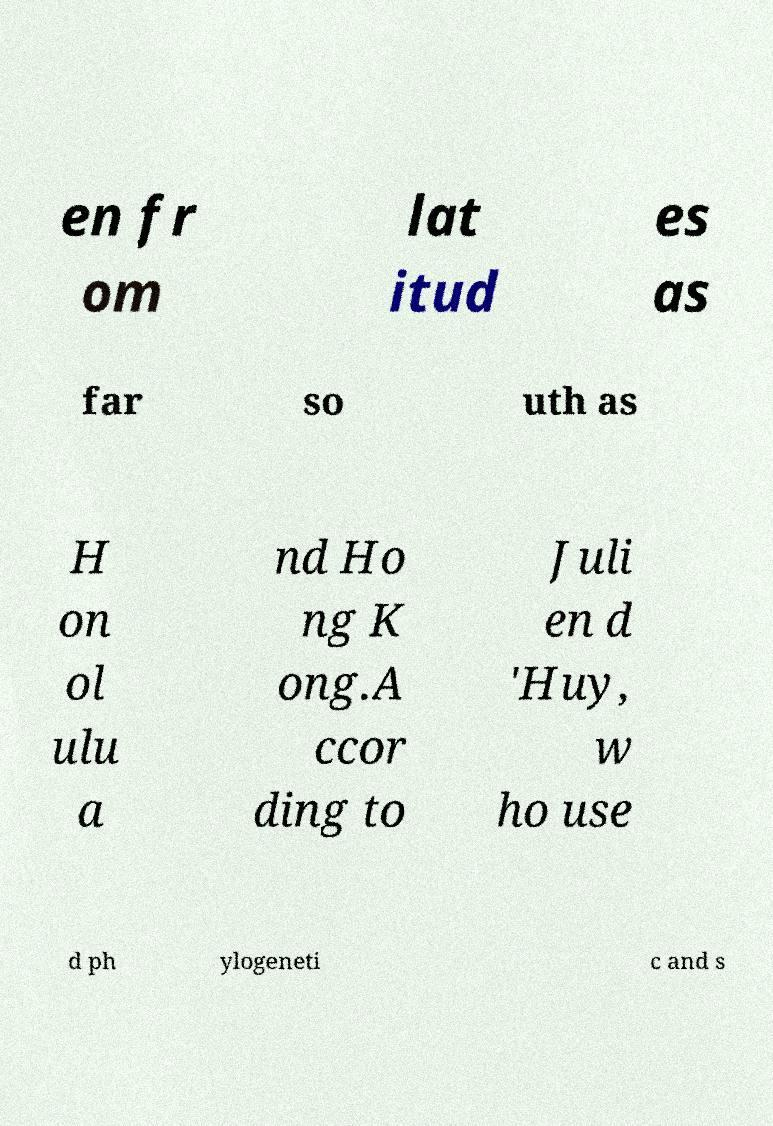I need the written content from this picture converted into text. Can you do that? en fr om lat itud es as far so uth as H on ol ulu a nd Ho ng K ong.A ccor ding to Juli en d 'Huy, w ho use d ph ylogeneti c and s 